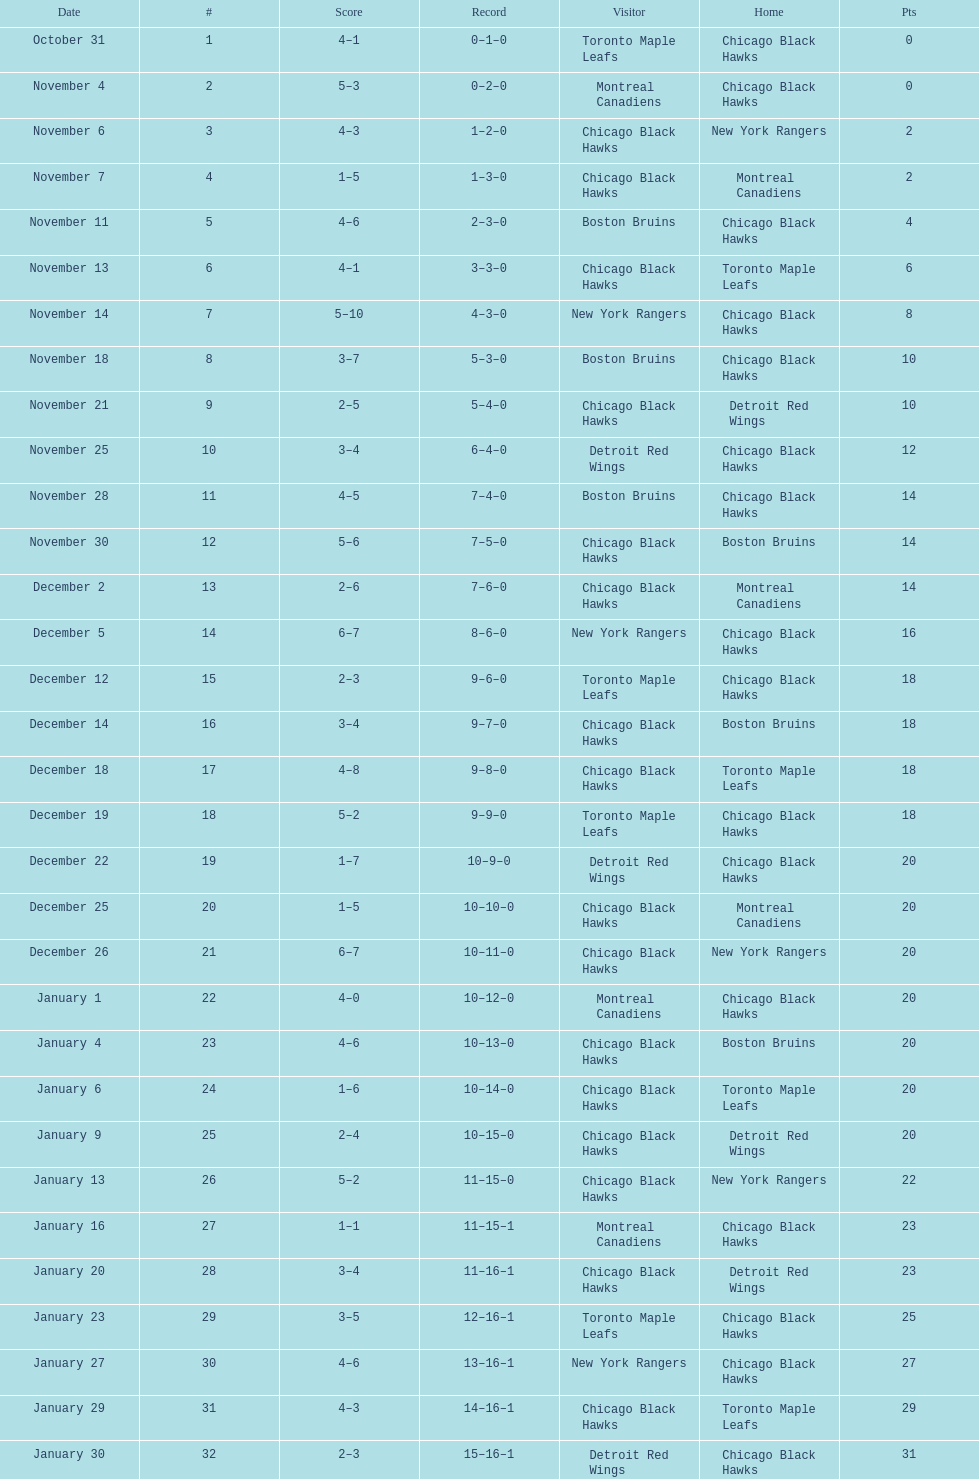Which team was the first one the black hawks lost to? Toronto Maple Leafs. 